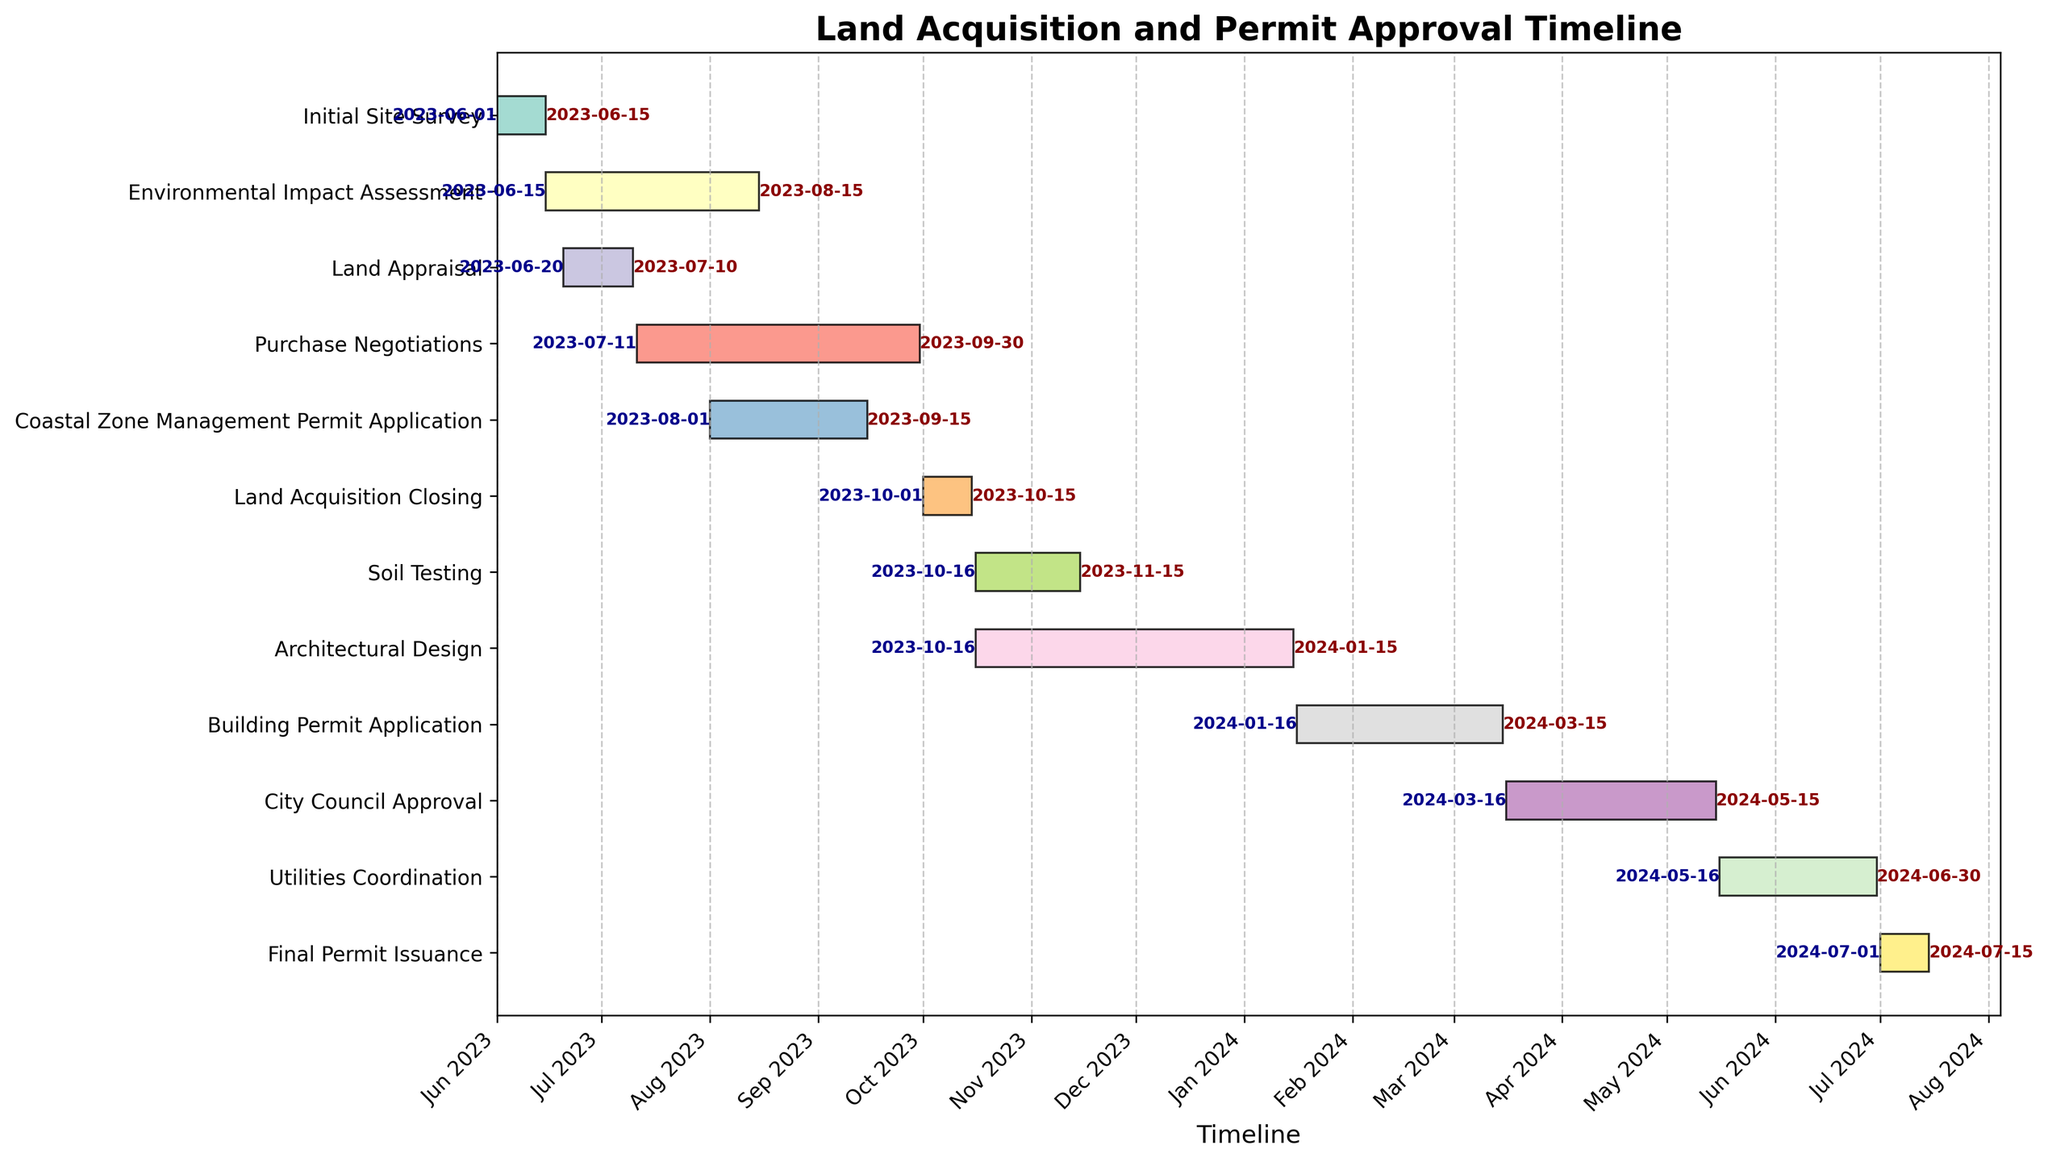What is the title of the figure? The title of the figure is displayed prominently at the top and reads "Land Acquisition and Permit Approval Timeline."
Answer: Land Acquisition and Permit Approval Timeline When does the "Environmental Impact Assessment" task start and end? Find the bar labeled "Environmental Impact Assessment" and check its start and end annotations. It starts on 2023-06-15 and ends on 2023-08-15.
Answer: 2023-06-15 to 2023-08-15 Which task has the shortest duration, and what is its duration? Look for the bar with the smallest length. "Initial Site Survey" is the shortest, with a duration of 14 days (2023-06-01 to 2023-06-15).
Answer: Initial Site Survey, 14 days Which tasks are ongoing when "Land Acquisition Closing" begins? "Land Acquisition Closing" starts on 2023-10-01. Check which bars overlap with this date. "Soil Testing" and "Architectural Design" start on 2023-10-16, so they overlap.
Answer: Soil Testing and Architectural Design What is the total duration of the "Purchase Negotiations" task? Find the bar for "Purchase Negotiations" and calculate the number of days from the start (2023-07-11) to the end (2023-09-30). It spans 81 days.
Answer: 81 days Compare the durations of "Building Permit Application" and "City Council Approval." Which one is longer, and by how many days? Calculate the durations of "Building Permit Application" (2024-01-16 to 2024-03-15) and "City Council Approval" (2024-03-16 to 2024-05-15). They are both 59 days long.
Answer: They are equal, 59 days Which task overlaps with at least three other tasks during its timeline? Identify tasks and count how many bars overlap for each. "Architectural Design" (2023-10-16 to 2024-01-15) overlaps with "Soil Testing," "Land Acquisition Closing," "Building Permit Application," and partially with "Purchase Negotiations."
Answer: Architectural Design When is the "Final Permit Issuance" scheduled to be completed? Find the end date for the "Final Permit Issuance" task. It's scheduled to be completed on 2024-07-15.
Answer: 2024-07-15 What is the combined duration of tasks from "Environmental Impact Assessment" to "Land Acquisition Closing"? Sum the durations of tasks from "Environmental Impact Assessment" (61 days), "Land Appraisal" (20 days), "Purchase Negotiations" (81 days), "Coastal Zone Management Permit Application" (45 days), and "Land Acquisition Closing" (15 days). The combined duration is 222 days.
Answer: 222 days 